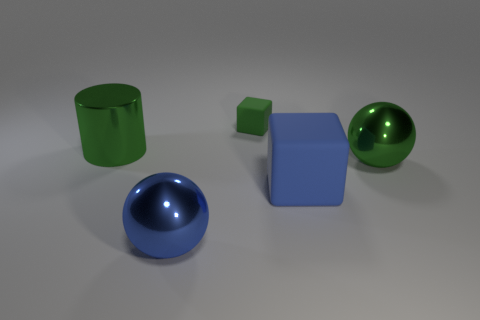What is the size of the object that is left of the big green metal ball and to the right of the tiny green matte block?
Keep it short and to the point. Large. Do the large ball behind the large blue block and the cube that is to the right of the green rubber cube have the same color?
Your answer should be compact. No. How many blue blocks are in front of the large green cylinder?
Ensure brevity in your answer.  1. There is a metallic sphere to the left of the big shiny object right of the blue block; are there any metallic things that are left of it?
Offer a terse response. Yes. What number of blue cylinders have the same size as the blue shiny object?
Offer a very short reply. 0. There is a block that is behind the rubber cube that is to the right of the green rubber block; what is it made of?
Offer a terse response. Rubber. What is the shape of the large thing behind the green shiny thing in front of the green shiny object behind the green metal sphere?
Provide a short and direct response. Cylinder. Do the green thing in front of the cylinder and the large blue object that is right of the green rubber object have the same shape?
Your answer should be compact. No. How many other things are there of the same material as the large green sphere?
Give a very brief answer. 2. What shape is the green thing that is made of the same material as the big green ball?
Offer a very short reply. Cylinder. 